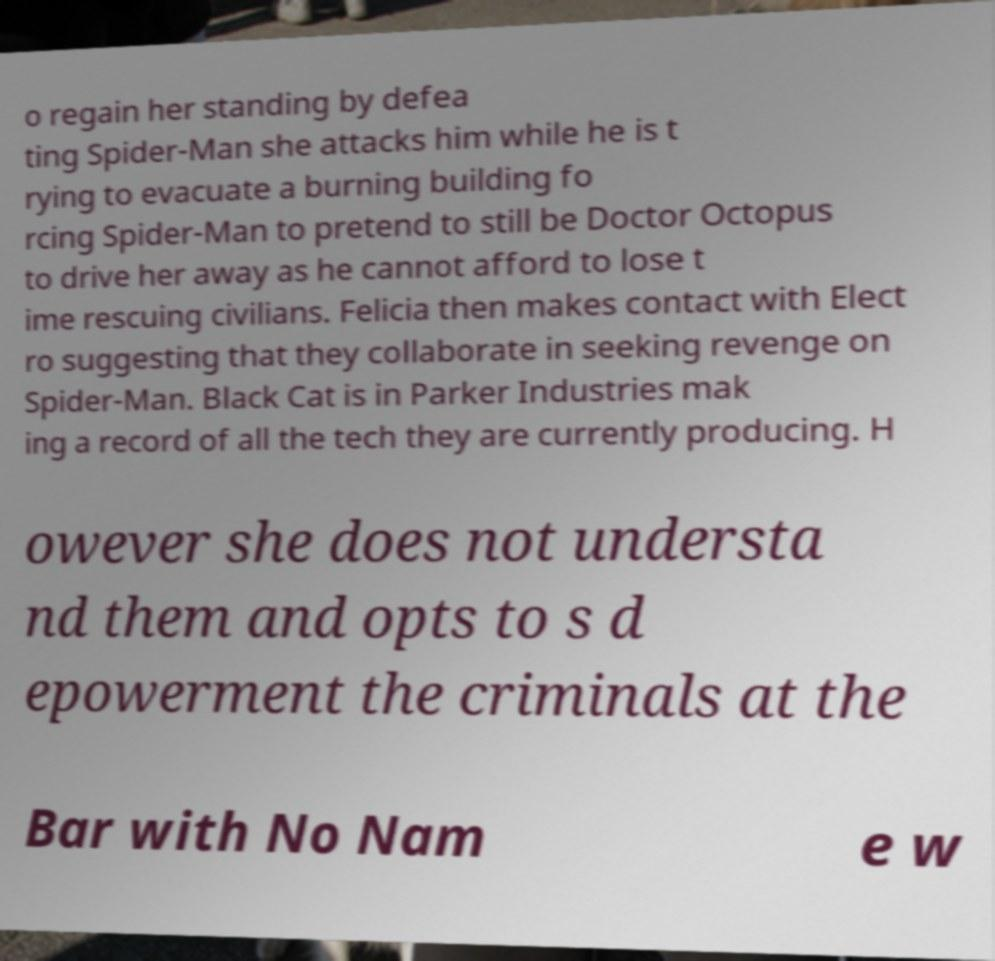Can you accurately transcribe the text from the provided image for me? o regain her standing by defea ting Spider-Man she attacks him while he is t rying to evacuate a burning building fo rcing Spider-Man to pretend to still be Doctor Octopus to drive her away as he cannot afford to lose t ime rescuing civilians. Felicia then makes contact with Elect ro suggesting that they collaborate in seeking revenge on Spider-Man. Black Cat is in Parker Industries mak ing a record of all the tech they are currently producing. H owever she does not understa nd them and opts to s d epowerment the criminals at the Bar with No Nam e w 